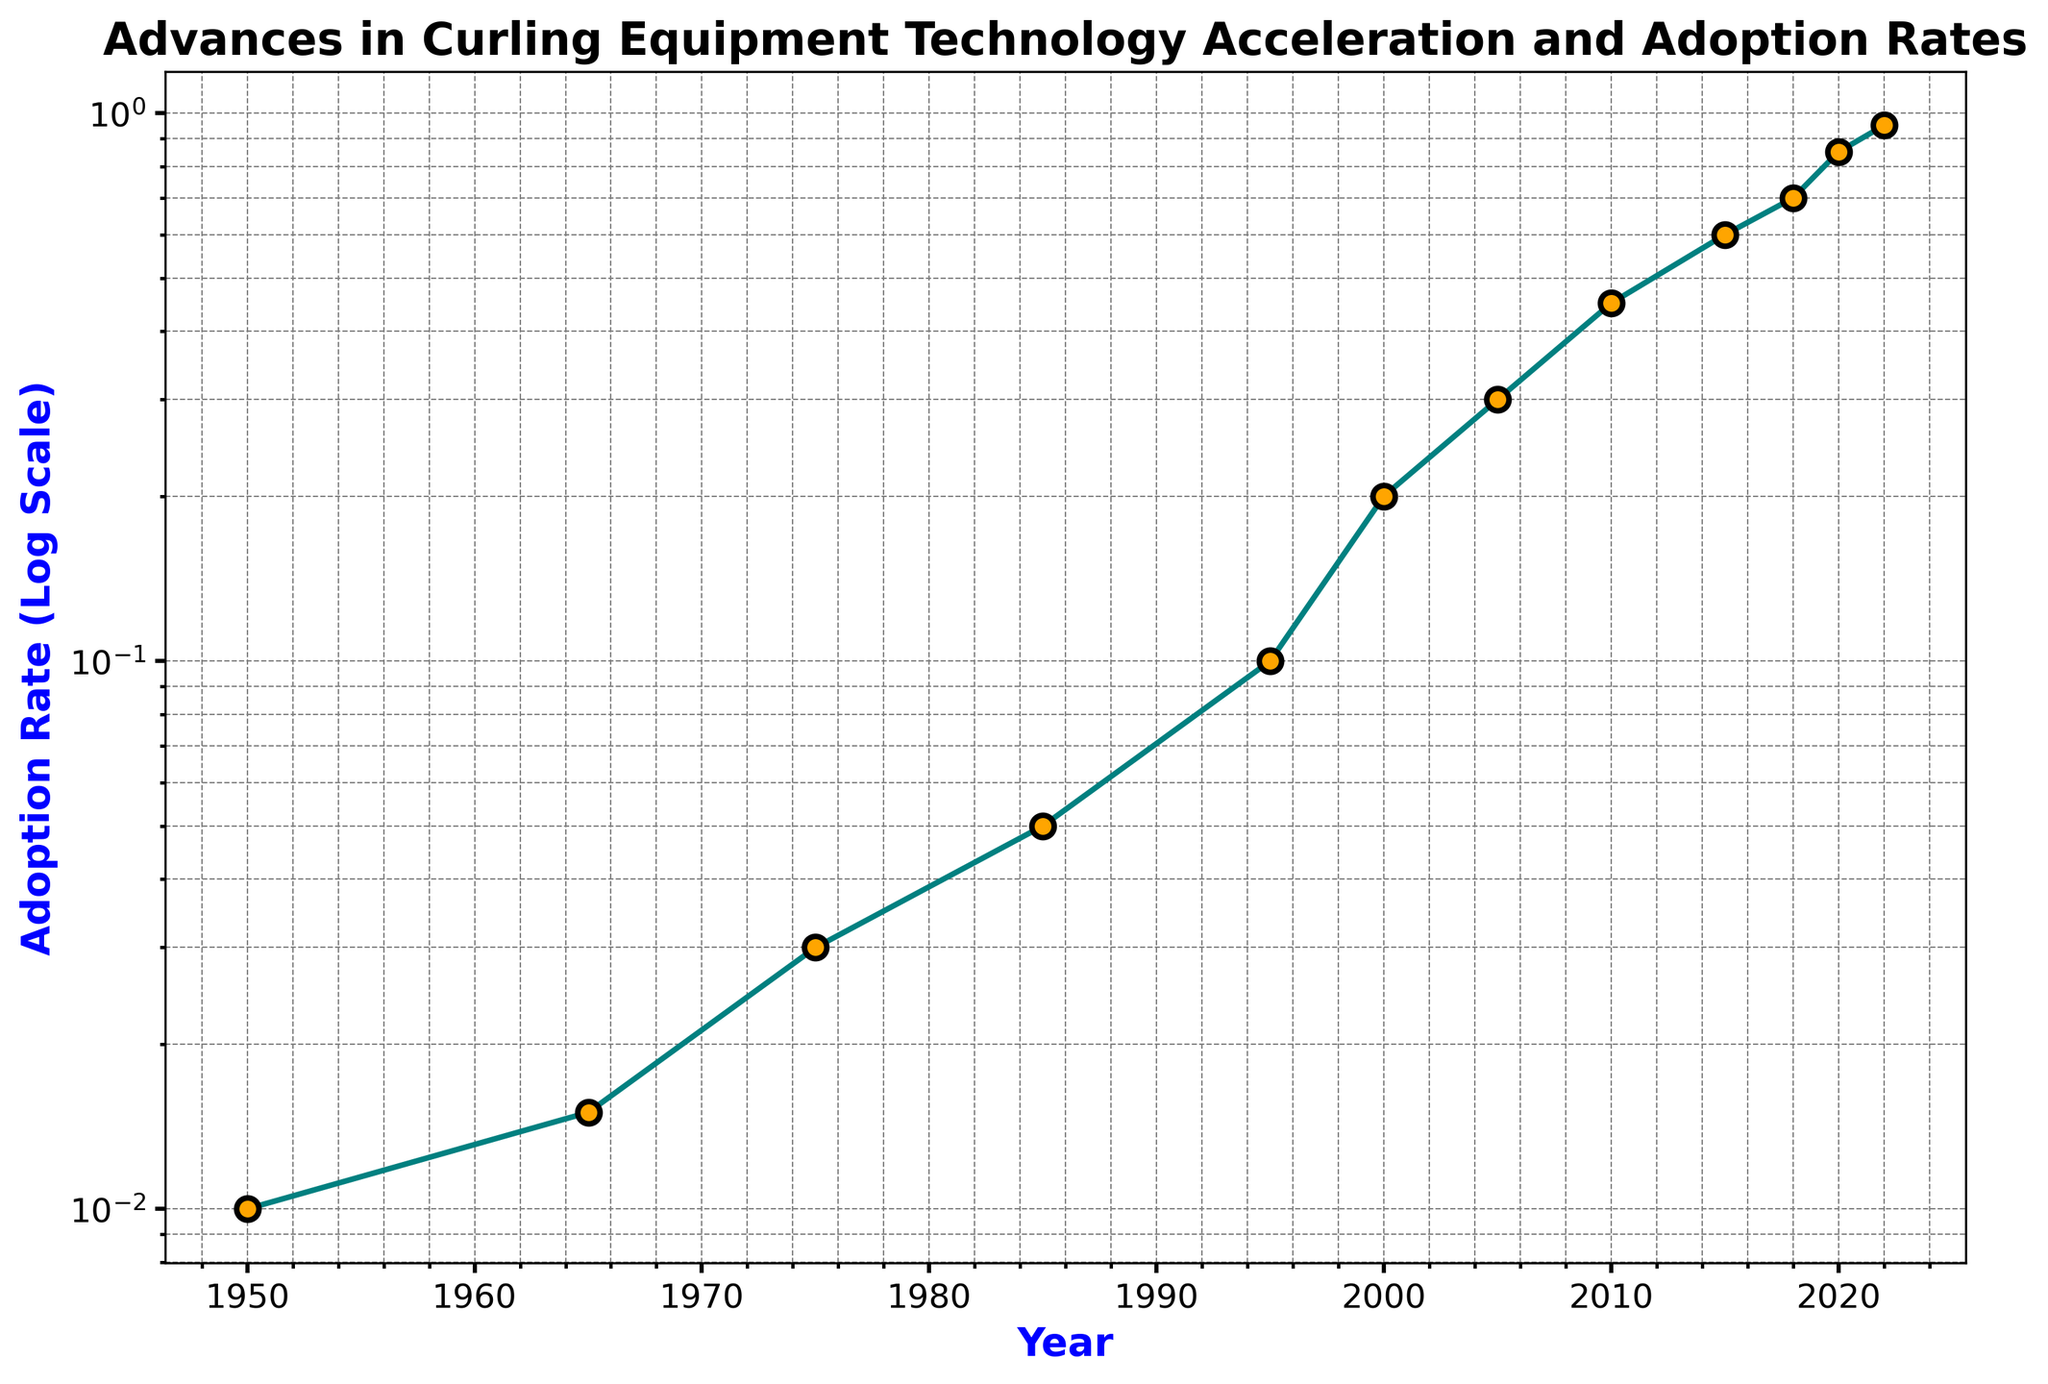Which invention saw the highest adoption rate in 2018? The year 2018 corresponds to Smart Broom Technologies with an adoption rate of 0.70.
Answer: Smart Broom Technologies Which two inventions had an adoption rate greater than 0.50 and identify them? By looking at the data points with an adoption rate beyond 0.50, we find Electronic Hog Line Sensors (0.60 in 2015) and AI Video Analysis for Coaching (0.85 in 2020).
Answer: Electronic Hog Line Sensors, AI Video Analysis for Coaching How did the adoption rate change between 1975 and 2005? The adoption rate increased from 0.03 in 1975 (Sliders on Shoes) to 0.30 in 2005 (Enhanced Ceramic Pebbling), which is an increment of 0.27.
Answer: +0.27 What is the difference in adoption rate between Personalized Broom Handles and Precision Ice-Making Equipment? Adoption rate of Personalized Broom Handles in 1995 is 0.10 and Precision Ice-Making Equipment in 2000 is 0.20; the difference is 0.10.
Answer: 0.10 Which invention occurred first, Lightweight Granite Stones or Adjustable Brooms, and in which year did it happen? Lightweight Granite Stones occurred in 1950, whereas Adjustable Brooms emerged in 1985. Hence, Lightweight Granite Stones came first.
Answer: Lightweight Granite Stones, 1950 When did the adoption rate first exceed 0.40? The figure shows that the adoption rate exceeded 0.40 in 2010 with the advent of High-Tech Curling Shoes.
Answer: 2010 Compare the adoption rates of the years 1965 and 1985, which year had the higher rate and by how much? In 1965, the adoption rate is 0.015 (Synthetic Broom Materials) while in 1985 it is 0.05 (Adjustable Brooms), making 1985 higher by 0.035.
Answer: 1985, 0.035 Which advancements occurred one after the other between 2000 and 2022, and what is the overall trend in adoption rate? Starting from 2000, the advancements were Precision Ice-Making Equipment, Enhanced Ceramic Pebbling, High-Tech Curling Shoes, Electronic Hog Line Sensors, Smart Broom Technologies, AI Video Analysis for Coaching, and Advanced Ice Prediction Software. The overall trend shows a sharp increase in adoption rate.
Answer: Precision Ice-Making Equipment, Enhanced Ceramic Pebbling, High-Tech Curling Shoes, Electronic Hog Line Sensors, Smart Broom Technologies, AI Video Analysis for Coaching, Advanced Ice Prediction Software; Increasing What is the visual significance of the markers on the plot and what varies with them? The markers, which are orange circles outlined in black, represent individual inventions with their sizes and borders highlighting the importance of each data point. The adoption rate varies with each marker.
Answer: Markers indicate inventions with varying adoption rates 